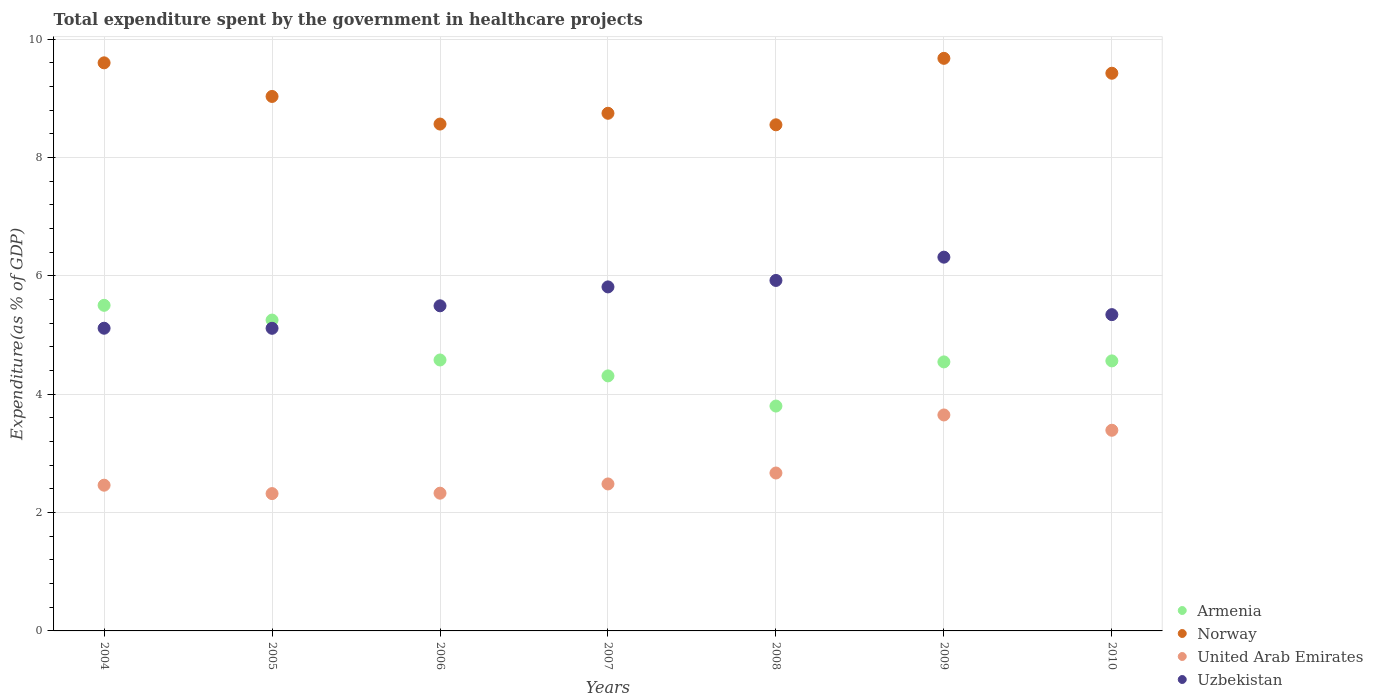What is the total expenditure spent by the government in healthcare projects in United Arab Emirates in 2010?
Make the answer very short. 3.39. Across all years, what is the maximum total expenditure spent by the government in healthcare projects in Uzbekistan?
Provide a succinct answer. 6.31. Across all years, what is the minimum total expenditure spent by the government in healthcare projects in Norway?
Your response must be concise. 8.55. In which year was the total expenditure spent by the government in healthcare projects in Armenia minimum?
Provide a succinct answer. 2008. What is the total total expenditure spent by the government in healthcare projects in Uzbekistan in the graph?
Make the answer very short. 39.11. What is the difference between the total expenditure spent by the government in healthcare projects in Norway in 2008 and that in 2009?
Your response must be concise. -1.12. What is the difference between the total expenditure spent by the government in healthcare projects in Norway in 2006 and the total expenditure spent by the government in healthcare projects in Armenia in 2010?
Make the answer very short. 4. What is the average total expenditure spent by the government in healthcare projects in United Arab Emirates per year?
Offer a terse response. 2.76. In the year 2005, what is the difference between the total expenditure spent by the government in healthcare projects in United Arab Emirates and total expenditure spent by the government in healthcare projects in Uzbekistan?
Provide a succinct answer. -2.79. What is the ratio of the total expenditure spent by the government in healthcare projects in United Arab Emirates in 2005 to that in 2008?
Make the answer very short. 0.87. Is the total expenditure spent by the government in healthcare projects in United Arab Emirates in 2005 less than that in 2006?
Provide a short and direct response. Yes. Is the difference between the total expenditure spent by the government in healthcare projects in United Arab Emirates in 2005 and 2008 greater than the difference between the total expenditure spent by the government in healthcare projects in Uzbekistan in 2005 and 2008?
Offer a very short reply. Yes. What is the difference between the highest and the second highest total expenditure spent by the government in healthcare projects in United Arab Emirates?
Offer a terse response. 0.26. What is the difference between the highest and the lowest total expenditure spent by the government in healthcare projects in Norway?
Your answer should be very brief. 1.12. Does the total expenditure spent by the government in healthcare projects in Uzbekistan monotonically increase over the years?
Your response must be concise. No. Is the total expenditure spent by the government in healthcare projects in United Arab Emirates strictly greater than the total expenditure spent by the government in healthcare projects in Norway over the years?
Make the answer very short. No. Is the total expenditure spent by the government in healthcare projects in Uzbekistan strictly less than the total expenditure spent by the government in healthcare projects in United Arab Emirates over the years?
Offer a terse response. No. How many dotlines are there?
Your answer should be compact. 4. What is the difference between two consecutive major ticks on the Y-axis?
Give a very brief answer. 2. Are the values on the major ticks of Y-axis written in scientific E-notation?
Provide a short and direct response. No. How are the legend labels stacked?
Give a very brief answer. Vertical. What is the title of the graph?
Your answer should be very brief. Total expenditure spent by the government in healthcare projects. Does "Virgin Islands" appear as one of the legend labels in the graph?
Make the answer very short. No. What is the label or title of the X-axis?
Provide a short and direct response. Years. What is the label or title of the Y-axis?
Make the answer very short. Expenditure(as % of GDP). What is the Expenditure(as % of GDP) of Armenia in 2004?
Your answer should be very brief. 5.5. What is the Expenditure(as % of GDP) of Norway in 2004?
Provide a succinct answer. 9.6. What is the Expenditure(as % of GDP) of United Arab Emirates in 2004?
Your response must be concise. 2.46. What is the Expenditure(as % of GDP) in Uzbekistan in 2004?
Make the answer very short. 5.11. What is the Expenditure(as % of GDP) in Armenia in 2005?
Provide a succinct answer. 5.25. What is the Expenditure(as % of GDP) in Norway in 2005?
Your response must be concise. 9.03. What is the Expenditure(as % of GDP) in United Arab Emirates in 2005?
Provide a succinct answer. 2.32. What is the Expenditure(as % of GDP) in Uzbekistan in 2005?
Offer a terse response. 5.11. What is the Expenditure(as % of GDP) in Armenia in 2006?
Your response must be concise. 4.58. What is the Expenditure(as % of GDP) in Norway in 2006?
Make the answer very short. 8.56. What is the Expenditure(as % of GDP) in United Arab Emirates in 2006?
Keep it short and to the point. 2.33. What is the Expenditure(as % of GDP) of Uzbekistan in 2006?
Provide a succinct answer. 5.49. What is the Expenditure(as % of GDP) of Armenia in 2007?
Your answer should be very brief. 4.31. What is the Expenditure(as % of GDP) of Norway in 2007?
Your answer should be very brief. 8.75. What is the Expenditure(as % of GDP) of United Arab Emirates in 2007?
Make the answer very short. 2.48. What is the Expenditure(as % of GDP) of Uzbekistan in 2007?
Provide a short and direct response. 5.81. What is the Expenditure(as % of GDP) in Armenia in 2008?
Keep it short and to the point. 3.8. What is the Expenditure(as % of GDP) in Norway in 2008?
Give a very brief answer. 8.55. What is the Expenditure(as % of GDP) of United Arab Emirates in 2008?
Offer a terse response. 2.67. What is the Expenditure(as % of GDP) in Uzbekistan in 2008?
Your answer should be very brief. 5.92. What is the Expenditure(as % of GDP) of Armenia in 2009?
Provide a short and direct response. 4.55. What is the Expenditure(as % of GDP) of Norway in 2009?
Your answer should be compact. 9.67. What is the Expenditure(as % of GDP) of United Arab Emirates in 2009?
Your response must be concise. 3.65. What is the Expenditure(as % of GDP) in Uzbekistan in 2009?
Provide a succinct answer. 6.31. What is the Expenditure(as % of GDP) of Armenia in 2010?
Keep it short and to the point. 4.56. What is the Expenditure(as % of GDP) of Norway in 2010?
Make the answer very short. 9.42. What is the Expenditure(as % of GDP) of United Arab Emirates in 2010?
Keep it short and to the point. 3.39. What is the Expenditure(as % of GDP) of Uzbekistan in 2010?
Ensure brevity in your answer.  5.34. Across all years, what is the maximum Expenditure(as % of GDP) of Armenia?
Offer a very short reply. 5.5. Across all years, what is the maximum Expenditure(as % of GDP) of Norway?
Give a very brief answer. 9.67. Across all years, what is the maximum Expenditure(as % of GDP) of United Arab Emirates?
Your answer should be compact. 3.65. Across all years, what is the maximum Expenditure(as % of GDP) in Uzbekistan?
Ensure brevity in your answer.  6.31. Across all years, what is the minimum Expenditure(as % of GDP) in Armenia?
Provide a short and direct response. 3.8. Across all years, what is the minimum Expenditure(as % of GDP) of Norway?
Your answer should be very brief. 8.55. Across all years, what is the minimum Expenditure(as % of GDP) in United Arab Emirates?
Provide a succinct answer. 2.32. Across all years, what is the minimum Expenditure(as % of GDP) of Uzbekistan?
Keep it short and to the point. 5.11. What is the total Expenditure(as % of GDP) in Armenia in the graph?
Your response must be concise. 32.55. What is the total Expenditure(as % of GDP) of Norway in the graph?
Give a very brief answer. 63.59. What is the total Expenditure(as % of GDP) in United Arab Emirates in the graph?
Your answer should be compact. 19.3. What is the total Expenditure(as % of GDP) of Uzbekistan in the graph?
Provide a succinct answer. 39.11. What is the difference between the Expenditure(as % of GDP) in Armenia in 2004 and that in 2005?
Give a very brief answer. 0.25. What is the difference between the Expenditure(as % of GDP) in Norway in 2004 and that in 2005?
Offer a terse response. 0.57. What is the difference between the Expenditure(as % of GDP) in United Arab Emirates in 2004 and that in 2005?
Make the answer very short. 0.14. What is the difference between the Expenditure(as % of GDP) of Uzbekistan in 2004 and that in 2005?
Keep it short and to the point. 0. What is the difference between the Expenditure(as % of GDP) in Armenia in 2004 and that in 2006?
Offer a terse response. 0.92. What is the difference between the Expenditure(as % of GDP) of Norway in 2004 and that in 2006?
Keep it short and to the point. 1.03. What is the difference between the Expenditure(as % of GDP) of United Arab Emirates in 2004 and that in 2006?
Offer a terse response. 0.13. What is the difference between the Expenditure(as % of GDP) of Uzbekistan in 2004 and that in 2006?
Your answer should be compact. -0.38. What is the difference between the Expenditure(as % of GDP) in Armenia in 2004 and that in 2007?
Make the answer very short. 1.19. What is the difference between the Expenditure(as % of GDP) of Norway in 2004 and that in 2007?
Your answer should be compact. 0.85. What is the difference between the Expenditure(as % of GDP) in United Arab Emirates in 2004 and that in 2007?
Your answer should be very brief. -0.02. What is the difference between the Expenditure(as % of GDP) of Uzbekistan in 2004 and that in 2007?
Ensure brevity in your answer.  -0.7. What is the difference between the Expenditure(as % of GDP) of Armenia in 2004 and that in 2008?
Your response must be concise. 1.7. What is the difference between the Expenditure(as % of GDP) in Norway in 2004 and that in 2008?
Make the answer very short. 1.05. What is the difference between the Expenditure(as % of GDP) in United Arab Emirates in 2004 and that in 2008?
Your answer should be very brief. -0.21. What is the difference between the Expenditure(as % of GDP) in Uzbekistan in 2004 and that in 2008?
Keep it short and to the point. -0.81. What is the difference between the Expenditure(as % of GDP) of Armenia in 2004 and that in 2009?
Provide a short and direct response. 0.96. What is the difference between the Expenditure(as % of GDP) of Norway in 2004 and that in 2009?
Give a very brief answer. -0.08. What is the difference between the Expenditure(as % of GDP) of United Arab Emirates in 2004 and that in 2009?
Your answer should be compact. -1.19. What is the difference between the Expenditure(as % of GDP) of Uzbekistan in 2004 and that in 2009?
Give a very brief answer. -1.2. What is the difference between the Expenditure(as % of GDP) in Armenia in 2004 and that in 2010?
Offer a very short reply. 0.94. What is the difference between the Expenditure(as % of GDP) of Norway in 2004 and that in 2010?
Ensure brevity in your answer.  0.18. What is the difference between the Expenditure(as % of GDP) in United Arab Emirates in 2004 and that in 2010?
Provide a succinct answer. -0.93. What is the difference between the Expenditure(as % of GDP) in Uzbekistan in 2004 and that in 2010?
Your answer should be very brief. -0.23. What is the difference between the Expenditure(as % of GDP) of Armenia in 2005 and that in 2006?
Provide a short and direct response. 0.67. What is the difference between the Expenditure(as % of GDP) in Norway in 2005 and that in 2006?
Keep it short and to the point. 0.47. What is the difference between the Expenditure(as % of GDP) of United Arab Emirates in 2005 and that in 2006?
Provide a succinct answer. -0.01. What is the difference between the Expenditure(as % of GDP) of Uzbekistan in 2005 and that in 2006?
Provide a short and direct response. -0.38. What is the difference between the Expenditure(as % of GDP) in Armenia in 2005 and that in 2007?
Your response must be concise. 0.94. What is the difference between the Expenditure(as % of GDP) of Norway in 2005 and that in 2007?
Offer a very short reply. 0.28. What is the difference between the Expenditure(as % of GDP) of United Arab Emirates in 2005 and that in 2007?
Provide a short and direct response. -0.16. What is the difference between the Expenditure(as % of GDP) in Uzbekistan in 2005 and that in 2007?
Provide a short and direct response. -0.7. What is the difference between the Expenditure(as % of GDP) of Armenia in 2005 and that in 2008?
Offer a very short reply. 1.45. What is the difference between the Expenditure(as % of GDP) in Norway in 2005 and that in 2008?
Your answer should be compact. 0.48. What is the difference between the Expenditure(as % of GDP) of United Arab Emirates in 2005 and that in 2008?
Offer a terse response. -0.35. What is the difference between the Expenditure(as % of GDP) of Uzbekistan in 2005 and that in 2008?
Ensure brevity in your answer.  -0.81. What is the difference between the Expenditure(as % of GDP) in Armenia in 2005 and that in 2009?
Provide a succinct answer. 0.71. What is the difference between the Expenditure(as % of GDP) in Norway in 2005 and that in 2009?
Your response must be concise. -0.64. What is the difference between the Expenditure(as % of GDP) of United Arab Emirates in 2005 and that in 2009?
Provide a succinct answer. -1.33. What is the difference between the Expenditure(as % of GDP) of Uzbekistan in 2005 and that in 2009?
Offer a very short reply. -1.2. What is the difference between the Expenditure(as % of GDP) of Armenia in 2005 and that in 2010?
Offer a very short reply. 0.69. What is the difference between the Expenditure(as % of GDP) in Norway in 2005 and that in 2010?
Your response must be concise. -0.39. What is the difference between the Expenditure(as % of GDP) of United Arab Emirates in 2005 and that in 2010?
Provide a short and direct response. -1.07. What is the difference between the Expenditure(as % of GDP) in Uzbekistan in 2005 and that in 2010?
Keep it short and to the point. -0.23. What is the difference between the Expenditure(as % of GDP) of Armenia in 2006 and that in 2007?
Offer a terse response. 0.27. What is the difference between the Expenditure(as % of GDP) in Norway in 2006 and that in 2007?
Your answer should be compact. -0.18. What is the difference between the Expenditure(as % of GDP) in United Arab Emirates in 2006 and that in 2007?
Provide a succinct answer. -0.16. What is the difference between the Expenditure(as % of GDP) of Uzbekistan in 2006 and that in 2007?
Provide a short and direct response. -0.32. What is the difference between the Expenditure(as % of GDP) in Armenia in 2006 and that in 2008?
Your response must be concise. 0.78. What is the difference between the Expenditure(as % of GDP) in Norway in 2006 and that in 2008?
Your answer should be compact. 0.01. What is the difference between the Expenditure(as % of GDP) of United Arab Emirates in 2006 and that in 2008?
Give a very brief answer. -0.34. What is the difference between the Expenditure(as % of GDP) in Uzbekistan in 2006 and that in 2008?
Give a very brief answer. -0.43. What is the difference between the Expenditure(as % of GDP) of Armenia in 2006 and that in 2009?
Keep it short and to the point. 0.03. What is the difference between the Expenditure(as % of GDP) of Norway in 2006 and that in 2009?
Your answer should be very brief. -1.11. What is the difference between the Expenditure(as % of GDP) of United Arab Emirates in 2006 and that in 2009?
Your response must be concise. -1.32. What is the difference between the Expenditure(as % of GDP) in Uzbekistan in 2006 and that in 2009?
Your answer should be compact. -0.82. What is the difference between the Expenditure(as % of GDP) of Armenia in 2006 and that in 2010?
Make the answer very short. 0.02. What is the difference between the Expenditure(as % of GDP) of Norway in 2006 and that in 2010?
Your answer should be very brief. -0.86. What is the difference between the Expenditure(as % of GDP) of United Arab Emirates in 2006 and that in 2010?
Offer a very short reply. -1.06. What is the difference between the Expenditure(as % of GDP) in Uzbekistan in 2006 and that in 2010?
Offer a terse response. 0.15. What is the difference between the Expenditure(as % of GDP) of Armenia in 2007 and that in 2008?
Ensure brevity in your answer.  0.51. What is the difference between the Expenditure(as % of GDP) in Norway in 2007 and that in 2008?
Offer a terse response. 0.19. What is the difference between the Expenditure(as % of GDP) in United Arab Emirates in 2007 and that in 2008?
Give a very brief answer. -0.18. What is the difference between the Expenditure(as % of GDP) of Uzbekistan in 2007 and that in 2008?
Your answer should be compact. -0.11. What is the difference between the Expenditure(as % of GDP) of Armenia in 2007 and that in 2009?
Your answer should be very brief. -0.24. What is the difference between the Expenditure(as % of GDP) in Norway in 2007 and that in 2009?
Your answer should be compact. -0.93. What is the difference between the Expenditure(as % of GDP) in United Arab Emirates in 2007 and that in 2009?
Provide a succinct answer. -1.17. What is the difference between the Expenditure(as % of GDP) of Uzbekistan in 2007 and that in 2009?
Provide a succinct answer. -0.5. What is the difference between the Expenditure(as % of GDP) in Armenia in 2007 and that in 2010?
Offer a terse response. -0.25. What is the difference between the Expenditure(as % of GDP) of Norway in 2007 and that in 2010?
Your response must be concise. -0.68. What is the difference between the Expenditure(as % of GDP) of United Arab Emirates in 2007 and that in 2010?
Offer a terse response. -0.91. What is the difference between the Expenditure(as % of GDP) of Uzbekistan in 2007 and that in 2010?
Provide a short and direct response. 0.47. What is the difference between the Expenditure(as % of GDP) of Armenia in 2008 and that in 2009?
Provide a short and direct response. -0.75. What is the difference between the Expenditure(as % of GDP) of Norway in 2008 and that in 2009?
Your response must be concise. -1.12. What is the difference between the Expenditure(as % of GDP) of United Arab Emirates in 2008 and that in 2009?
Provide a short and direct response. -0.98. What is the difference between the Expenditure(as % of GDP) of Uzbekistan in 2008 and that in 2009?
Ensure brevity in your answer.  -0.39. What is the difference between the Expenditure(as % of GDP) in Armenia in 2008 and that in 2010?
Your answer should be compact. -0.76. What is the difference between the Expenditure(as % of GDP) of Norway in 2008 and that in 2010?
Keep it short and to the point. -0.87. What is the difference between the Expenditure(as % of GDP) in United Arab Emirates in 2008 and that in 2010?
Make the answer very short. -0.72. What is the difference between the Expenditure(as % of GDP) of Uzbekistan in 2008 and that in 2010?
Ensure brevity in your answer.  0.58. What is the difference between the Expenditure(as % of GDP) of Armenia in 2009 and that in 2010?
Offer a terse response. -0.02. What is the difference between the Expenditure(as % of GDP) of Norway in 2009 and that in 2010?
Provide a succinct answer. 0.25. What is the difference between the Expenditure(as % of GDP) in United Arab Emirates in 2009 and that in 2010?
Your answer should be compact. 0.26. What is the difference between the Expenditure(as % of GDP) in Uzbekistan in 2009 and that in 2010?
Give a very brief answer. 0.97. What is the difference between the Expenditure(as % of GDP) of Armenia in 2004 and the Expenditure(as % of GDP) of Norway in 2005?
Keep it short and to the point. -3.53. What is the difference between the Expenditure(as % of GDP) of Armenia in 2004 and the Expenditure(as % of GDP) of United Arab Emirates in 2005?
Give a very brief answer. 3.18. What is the difference between the Expenditure(as % of GDP) in Armenia in 2004 and the Expenditure(as % of GDP) in Uzbekistan in 2005?
Offer a terse response. 0.39. What is the difference between the Expenditure(as % of GDP) in Norway in 2004 and the Expenditure(as % of GDP) in United Arab Emirates in 2005?
Ensure brevity in your answer.  7.28. What is the difference between the Expenditure(as % of GDP) of Norway in 2004 and the Expenditure(as % of GDP) of Uzbekistan in 2005?
Offer a very short reply. 4.49. What is the difference between the Expenditure(as % of GDP) in United Arab Emirates in 2004 and the Expenditure(as % of GDP) in Uzbekistan in 2005?
Offer a terse response. -2.65. What is the difference between the Expenditure(as % of GDP) of Armenia in 2004 and the Expenditure(as % of GDP) of Norway in 2006?
Your answer should be compact. -3.06. What is the difference between the Expenditure(as % of GDP) of Armenia in 2004 and the Expenditure(as % of GDP) of United Arab Emirates in 2006?
Your answer should be very brief. 3.17. What is the difference between the Expenditure(as % of GDP) in Armenia in 2004 and the Expenditure(as % of GDP) in Uzbekistan in 2006?
Your answer should be compact. 0.01. What is the difference between the Expenditure(as % of GDP) of Norway in 2004 and the Expenditure(as % of GDP) of United Arab Emirates in 2006?
Provide a short and direct response. 7.27. What is the difference between the Expenditure(as % of GDP) in Norway in 2004 and the Expenditure(as % of GDP) in Uzbekistan in 2006?
Your response must be concise. 4.11. What is the difference between the Expenditure(as % of GDP) in United Arab Emirates in 2004 and the Expenditure(as % of GDP) in Uzbekistan in 2006?
Offer a very short reply. -3.03. What is the difference between the Expenditure(as % of GDP) of Armenia in 2004 and the Expenditure(as % of GDP) of Norway in 2007?
Provide a short and direct response. -3.24. What is the difference between the Expenditure(as % of GDP) of Armenia in 2004 and the Expenditure(as % of GDP) of United Arab Emirates in 2007?
Make the answer very short. 3.02. What is the difference between the Expenditure(as % of GDP) in Armenia in 2004 and the Expenditure(as % of GDP) in Uzbekistan in 2007?
Keep it short and to the point. -0.31. What is the difference between the Expenditure(as % of GDP) in Norway in 2004 and the Expenditure(as % of GDP) in United Arab Emirates in 2007?
Your response must be concise. 7.11. What is the difference between the Expenditure(as % of GDP) in Norway in 2004 and the Expenditure(as % of GDP) in Uzbekistan in 2007?
Keep it short and to the point. 3.79. What is the difference between the Expenditure(as % of GDP) in United Arab Emirates in 2004 and the Expenditure(as % of GDP) in Uzbekistan in 2007?
Your response must be concise. -3.35. What is the difference between the Expenditure(as % of GDP) in Armenia in 2004 and the Expenditure(as % of GDP) in Norway in 2008?
Your answer should be very brief. -3.05. What is the difference between the Expenditure(as % of GDP) of Armenia in 2004 and the Expenditure(as % of GDP) of United Arab Emirates in 2008?
Your response must be concise. 2.83. What is the difference between the Expenditure(as % of GDP) of Armenia in 2004 and the Expenditure(as % of GDP) of Uzbekistan in 2008?
Provide a short and direct response. -0.42. What is the difference between the Expenditure(as % of GDP) of Norway in 2004 and the Expenditure(as % of GDP) of United Arab Emirates in 2008?
Offer a very short reply. 6.93. What is the difference between the Expenditure(as % of GDP) of Norway in 2004 and the Expenditure(as % of GDP) of Uzbekistan in 2008?
Offer a very short reply. 3.68. What is the difference between the Expenditure(as % of GDP) in United Arab Emirates in 2004 and the Expenditure(as % of GDP) in Uzbekistan in 2008?
Provide a short and direct response. -3.46. What is the difference between the Expenditure(as % of GDP) in Armenia in 2004 and the Expenditure(as % of GDP) in Norway in 2009?
Ensure brevity in your answer.  -4.17. What is the difference between the Expenditure(as % of GDP) of Armenia in 2004 and the Expenditure(as % of GDP) of United Arab Emirates in 2009?
Provide a succinct answer. 1.85. What is the difference between the Expenditure(as % of GDP) of Armenia in 2004 and the Expenditure(as % of GDP) of Uzbekistan in 2009?
Offer a very short reply. -0.81. What is the difference between the Expenditure(as % of GDP) in Norway in 2004 and the Expenditure(as % of GDP) in United Arab Emirates in 2009?
Provide a short and direct response. 5.95. What is the difference between the Expenditure(as % of GDP) in Norway in 2004 and the Expenditure(as % of GDP) in Uzbekistan in 2009?
Offer a very short reply. 3.28. What is the difference between the Expenditure(as % of GDP) in United Arab Emirates in 2004 and the Expenditure(as % of GDP) in Uzbekistan in 2009?
Give a very brief answer. -3.85. What is the difference between the Expenditure(as % of GDP) in Armenia in 2004 and the Expenditure(as % of GDP) in Norway in 2010?
Your response must be concise. -3.92. What is the difference between the Expenditure(as % of GDP) in Armenia in 2004 and the Expenditure(as % of GDP) in United Arab Emirates in 2010?
Give a very brief answer. 2.11. What is the difference between the Expenditure(as % of GDP) of Armenia in 2004 and the Expenditure(as % of GDP) of Uzbekistan in 2010?
Ensure brevity in your answer.  0.16. What is the difference between the Expenditure(as % of GDP) in Norway in 2004 and the Expenditure(as % of GDP) in United Arab Emirates in 2010?
Your answer should be very brief. 6.21. What is the difference between the Expenditure(as % of GDP) in Norway in 2004 and the Expenditure(as % of GDP) in Uzbekistan in 2010?
Offer a very short reply. 4.25. What is the difference between the Expenditure(as % of GDP) in United Arab Emirates in 2004 and the Expenditure(as % of GDP) in Uzbekistan in 2010?
Offer a very short reply. -2.88. What is the difference between the Expenditure(as % of GDP) of Armenia in 2005 and the Expenditure(as % of GDP) of Norway in 2006?
Ensure brevity in your answer.  -3.31. What is the difference between the Expenditure(as % of GDP) of Armenia in 2005 and the Expenditure(as % of GDP) of United Arab Emirates in 2006?
Provide a short and direct response. 2.92. What is the difference between the Expenditure(as % of GDP) in Armenia in 2005 and the Expenditure(as % of GDP) in Uzbekistan in 2006?
Make the answer very short. -0.24. What is the difference between the Expenditure(as % of GDP) of Norway in 2005 and the Expenditure(as % of GDP) of United Arab Emirates in 2006?
Your answer should be very brief. 6.7. What is the difference between the Expenditure(as % of GDP) of Norway in 2005 and the Expenditure(as % of GDP) of Uzbekistan in 2006?
Provide a short and direct response. 3.54. What is the difference between the Expenditure(as % of GDP) of United Arab Emirates in 2005 and the Expenditure(as % of GDP) of Uzbekistan in 2006?
Provide a short and direct response. -3.17. What is the difference between the Expenditure(as % of GDP) of Armenia in 2005 and the Expenditure(as % of GDP) of Norway in 2007?
Ensure brevity in your answer.  -3.49. What is the difference between the Expenditure(as % of GDP) in Armenia in 2005 and the Expenditure(as % of GDP) in United Arab Emirates in 2007?
Ensure brevity in your answer.  2.77. What is the difference between the Expenditure(as % of GDP) of Armenia in 2005 and the Expenditure(as % of GDP) of Uzbekistan in 2007?
Offer a terse response. -0.56. What is the difference between the Expenditure(as % of GDP) in Norway in 2005 and the Expenditure(as % of GDP) in United Arab Emirates in 2007?
Provide a succinct answer. 6.55. What is the difference between the Expenditure(as % of GDP) of Norway in 2005 and the Expenditure(as % of GDP) of Uzbekistan in 2007?
Offer a terse response. 3.22. What is the difference between the Expenditure(as % of GDP) in United Arab Emirates in 2005 and the Expenditure(as % of GDP) in Uzbekistan in 2007?
Provide a short and direct response. -3.49. What is the difference between the Expenditure(as % of GDP) of Armenia in 2005 and the Expenditure(as % of GDP) of Norway in 2008?
Give a very brief answer. -3.3. What is the difference between the Expenditure(as % of GDP) in Armenia in 2005 and the Expenditure(as % of GDP) in United Arab Emirates in 2008?
Keep it short and to the point. 2.58. What is the difference between the Expenditure(as % of GDP) in Armenia in 2005 and the Expenditure(as % of GDP) in Uzbekistan in 2008?
Your answer should be compact. -0.67. What is the difference between the Expenditure(as % of GDP) in Norway in 2005 and the Expenditure(as % of GDP) in United Arab Emirates in 2008?
Give a very brief answer. 6.36. What is the difference between the Expenditure(as % of GDP) in Norway in 2005 and the Expenditure(as % of GDP) in Uzbekistan in 2008?
Make the answer very short. 3.11. What is the difference between the Expenditure(as % of GDP) in United Arab Emirates in 2005 and the Expenditure(as % of GDP) in Uzbekistan in 2008?
Provide a succinct answer. -3.6. What is the difference between the Expenditure(as % of GDP) in Armenia in 2005 and the Expenditure(as % of GDP) in Norway in 2009?
Ensure brevity in your answer.  -4.42. What is the difference between the Expenditure(as % of GDP) in Armenia in 2005 and the Expenditure(as % of GDP) in United Arab Emirates in 2009?
Keep it short and to the point. 1.6. What is the difference between the Expenditure(as % of GDP) of Armenia in 2005 and the Expenditure(as % of GDP) of Uzbekistan in 2009?
Make the answer very short. -1.06. What is the difference between the Expenditure(as % of GDP) of Norway in 2005 and the Expenditure(as % of GDP) of United Arab Emirates in 2009?
Your answer should be compact. 5.38. What is the difference between the Expenditure(as % of GDP) in Norway in 2005 and the Expenditure(as % of GDP) in Uzbekistan in 2009?
Keep it short and to the point. 2.72. What is the difference between the Expenditure(as % of GDP) in United Arab Emirates in 2005 and the Expenditure(as % of GDP) in Uzbekistan in 2009?
Offer a terse response. -3.99. What is the difference between the Expenditure(as % of GDP) in Armenia in 2005 and the Expenditure(as % of GDP) in Norway in 2010?
Your answer should be compact. -4.17. What is the difference between the Expenditure(as % of GDP) of Armenia in 2005 and the Expenditure(as % of GDP) of United Arab Emirates in 2010?
Give a very brief answer. 1.86. What is the difference between the Expenditure(as % of GDP) in Armenia in 2005 and the Expenditure(as % of GDP) in Uzbekistan in 2010?
Your response must be concise. -0.09. What is the difference between the Expenditure(as % of GDP) of Norway in 2005 and the Expenditure(as % of GDP) of United Arab Emirates in 2010?
Make the answer very short. 5.64. What is the difference between the Expenditure(as % of GDP) in Norway in 2005 and the Expenditure(as % of GDP) in Uzbekistan in 2010?
Provide a short and direct response. 3.69. What is the difference between the Expenditure(as % of GDP) of United Arab Emirates in 2005 and the Expenditure(as % of GDP) of Uzbekistan in 2010?
Make the answer very short. -3.02. What is the difference between the Expenditure(as % of GDP) of Armenia in 2006 and the Expenditure(as % of GDP) of Norway in 2007?
Make the answer very short. -4.17. What is the difference between the Expenditure(as % of GDP) in Armenia in 2006 and the Expenditure(as % of GDP) in United Arab Emirates in 2007?
Give a very brief answer. 2.09. What is the difference between the Expenditure(as % of GDP) of Armenia in 2006 and the Expenditure(as % of GDP) of Uzbekistan in 2007?
Your answer should be very brief. -1.23. What is the difference between the Expenditure(as % of GDP) in Norway in 2006 and the Expenditure(as % of GDP) in United Arab Emirates in 2007?
Offer a very short reply. 6.08. What is the difference between the Expenditure(as % of GDP) in Norway in 2006 and the Expenditure(as % of GDP) in Uzbekistan in 2007?
Your answer should be compact. 2.75. What is the difference between the Expenditure(as % of GDP) of United Arab Emirates in 2006 and the Expenditure(as % of GDP) of Uzbekistan in 2007?
Give a very brief answer. -3.49. What is the difference between the Expenditure(as % of GDP) in Armenia in 2006 and the Expenditure(as % of GDP) in Norway in 2008?
Make the answer very short. -3.97. What is the difference between the Expenditure(as % of GDP) in Armenia in 2006 and the Expenditure(as % of GDP) in United Arab Emirates in 2008?
Provide a short and direct response. 1.91. What is the difference between the Expenditure(as % of GDP) of Armenia in 2006 and the Expenditure(as % of GDP) of Uzbekistan in 2008?
Offer a terse response. -1.34. What is the difference between the Expenditure(as % of GDP) of Norway in 2006 and the Expenditure(as % of GDP) of United Arab Emirates in 2008?
Your answer should be compact. 5.9. What is the difference between the Expenditure(as % of GDP) of Norway in 2006 and the Expenditure(as % of GDP) of Uzbekistan in 2008?
Give a very brief answer. 2.64. What is the difference between the Expenditure(as % of GDP) in United Arab Emirates in 2006 and the Expenditure(as % of GDP) in Uzbekistan in 2008?
Your answer should be very brief. -3.59. What is the difference between the Expenditure(as % of GDP) in Armenia in 2006 and the Expenditure(as % of GDP) in Norway in 2009?
Keep it short and to the point. -5.1. What is the difference between the Expenditure(as % of GDP) of Armenia in 2006 and the Expenditure(as % of GDP) of United Arab Emirates in 2009?
Your answer should be compact. 0.93. What is the difference between the Expenditure(as % of GDP) of Armenia in 2006 and the Expenditure(as % of GDP) of Uzbekistan in 2009?
Provide a short and direct response. -1.74. What is the difference between the Expenditure(as % of GDP) in Norway in 2006 and the Expenditure(as % of GDP) in United Arab Emirates in 2009?
Provide a succinct answer. 4.92. What is the difference between the Expenditure(as % of GDP) of Norway in 2006 and the Expenditure(as % of GDP) of Uzbekistan in 2009?
Keep it short and to the point. 2.25. What is the difference between the Expenditure(as % of GDP) in United Arab Emirates in 2006 and the Expenditure(as % of GDP) in Uzbekistan in 2009?
Ensure brevity in your answer.  -3.99. What is the difference between the Expenditure(as % of GDP) in Armenia in 2006 and the Expenditure(as % of GDP) in Norway in 2010?
Keep it short and to the point. -4.84. What is the difference between the Expenditure(as % of GDP) in Armenia in 2006 and the Expenditure(as % of GDP) in United Arab Emirates in 2010?
Your answer should be compact. 1.19. What is the difference between the Expenditure(as % of GDP) in Armenia in 2006 and the Expenditure(as % of GDP) in Uzbekistan in 2010?
Provide a short and direct response. -0.77. What is the difference between the Expenditure(as % of GDP) in Norway in 2006 and the Expenditure(as % of GDP) in United Arab Emirates in 2010?
Offer a very short reply. 5.17. What is the difference between the Expenditure(as % of GDP) of Norway in 2006 and the Expenditure(as % of GDP) of Uzbekistan in 2010?
Offer a very short reply. 3.22. What is the difference between the Expenditure(as % of GDP) in United Arab Emirates in 2006 and the Expenditure(as % of GDP) in Uzbekistan in 2010?
Offer a very short reply. -3.02. What is the difference between the Expenditure(as % of GDP) in Armenia in 2007 and the Expenditure(as % of GDP) in Norway in 2008?
Your answer should be very brief. -4.24. What is the difference between the Expenditure(as % of GDP) of Armenia in 2007 and the Expenditure(as % of GDP) of United Arab Emirates in 2008?
Your answer should be very brief. 1.64. What is the difference between the Expenditure(as % of GDP) of Armenia in 2007 and the Expenditure(as % of GDP) of Uzbekistan in 2008?
Give a very brief answer. -1.61. What is the difference between the Expenditure(as % of GDP) of Norway in 2007 and the Expenditure(as % of GDP) of United Arab Emirates in 2008?
Provide a short and direct response. 6.08. What is the difference between the Expenditure(as % of GDP) in Norway in 2007 and the Expenditure(as % of GDP) in Uzbekistan in 2008?
Keep it short and to the point. 2.82. What is the difference between the Expenditure(as % of GDP) of United Arab Emirates in 2007 and the Expenditure(as % of GDP) of Uzbekistan in 2008?
Ensure brevity in your answer.  -3.44. What is the difference between the Expenditure(as % of GDP) of Armenia in 2007 and the Expenditure(as % of GDP) of Norway in 2009?
Your answer should be compact. -5.37. What is the difference between the Expenditure(as % of GDP) of Armenia in 2007 and the Expenditure(as % of GDP) of United Arab Emirates in 2009?
Keep it short and to the point. 0.66. What is the difference between the Expenditure(as % of GDP) in Armenia in 2007 and the Expenditure(as % of GDP) in Uzbekistan in 2009?
Provide a short and direct response. -2.01. What is the difference between the Expenditure(as % of GDP) of Norway in 2007 and the Expenditure(as % of GDP) of United Arab Emirates in 2009?
Ensure brevity in your answer.  5.1. What is the difference between the Expenditure(as % of GDP) in Norway in 2007 and the Expenditure(as % of GDP) in Uzbekistan in 2009?
Your answer should be very brief. 2.43. What is the difference between the Expenditure(as % of GDP) in United Arab Emirates in 2007 and the Expenditure(as % of GDP) in Uzbekistan in 2009?
Ensure brevity in your answer.  -3.83. What is the difference between the Expenditure(as % of GDP) in Armenia in 2007 and the Expenditure(as % of GDP) in Norway in 2010?
Your response must be concise. -5.11. What is the difference between the Expenditure(as % of GDP) of Armenia in 2007 and the Expenditure(as % of GDP) of United Arab Emirates in 2010?
Offer a very short reply. 0.92. What is the difference between the Expenditure(as % of GDP) of Armenia in 2007 and the Expenditure(as % of GDP) of Uzbekistan in 2010?
Offer a very short reply. -1.04. What is the difference between the Expenditure(as % of GDP) in Norway in 2007 and the Expenditure(as % of GDP) in United Arab Emirates in 2010?
Your answer should be compact. 5.36. What is the difference between the Expenditure(as % of GDP) of Norway in 2007 and the Expenditure(as % of GDP) of Uzbekistan in 2010?
Your answer should be very brief. 3.4. What is the difference between the Expenditure(as % of GDP) in United Arab Emirates in 2007 and the Expenditure(as % of GDP) in Uzbekistan in 2010?
Give a very brief answer. -2.86. What is the difference between the Expenditure(as % of GDP) in Armenia in 2008 and the Expenditure(as % of GDP) in Norway in 2009?
Your answer should be very brief. -5.87. What is the difference between the Expenditure(as % of GDP) of Armenia in 2008 and the Expenditure(as % of GDP) of United Arab Emirates in 2009?
Your answer should be compact. 0.15. What is the difference between the Expenditure(as % of GDP) in Armenia in 2008 and the Expenditure(as % of GDP) in Uzbekistan in 2009?
Offer a terse response. -2.52. What is the difference between the Expenditure(as % of GDP) in Norway in 2008 and the Expenditure(as % of GDP) in United Arab Emirates in 2009?
Your answer should be very brief. 4.9. What is the difference between the Expenditure(as % of GDP) of Norway in 2008 and the Expenditure(as % of GDP) of Uzbekistan in 2009?
Ensure brevity in your answer.  2.24. What is the difference between the Expenditure(as % of GDP) of United Arab Emirates in 2008 and the Expenditure(as % of GDP) of Uzbekistan in 2009?
Provide a short and direct response. -3.65. What is the difference between the Expenditure(as % of GDP) of Armenia in 2008 and the Expenditure(as % of GDP) of Norway in 2010?
Offer a very short reply. -5.62. What is the difference between the Expenditure(as % of GDP) of Armenia in 2008 and the Expenditure(as % of GDP) of United Arab Emirates in 2010?
Offer a terse response. 0.41. What is the difference between the Expenditure(as % of GDP) in Armenia in 2008 and the Expenditure(as % of GDP) in Uzbekistan in 2010?
Provide a short and direct response. -1.54. What is the difference between the Expenditure(as % of GDP) of Norway in 2008 and the Expenditure(as % of GDP) of United Arab Emirates in 2010?
Your answer should be compact. 5.16. What is the difference between the Expenditure(as % of GDP) of Norway in 2008 and the Expenditure(as % of GDP) of Uzbekistan in 2010?
Provide a short and direct response. 3.21. What is the difference between the Expenditure(as % of GDP) of United Arab Emirates in 2008 and the Expenditure(as % of GDP) of Uzbekistan in 2010?
Make the answer very short. -2.68. What is the difference between the Expenditure(as % of GDP) of Armenia in 2009 and the Expenditure(as % of GDP) of Norway in 2010?
Your response must be concise. -4.88. What is the difference between the Expenditure(as % of GDP) in Armenia in 2009 and the Expenditure(as % of GDP) in United Arab Emirates in 2010?
Ensure brevity in your answer.  1.15. What is the difference between the Expenditure(as % of GDP) in Armenia in 2009 and the Expenditure(as % of GDP) in Uzbekistan in 2010?
Make the answer very short. -0.8. What is the difference between the Expenditure(as % of GDP) of Norway in 2009 and the Expenditure(as % of GDP) of United Arab Emirates in 2010?
Your response must be concise. 6.28. What is the difference between the Expenditure(as % of GDP) in Norway in 2009 and the Expenditure(as % of GDP) in Uzbekistan in 2010?
Your response must be concise. 4.33. What is the difference between the Expenditure(as % of GDP) in United Arab Emirates in 2009 and the Expenditure(as % of GDP) in Uzbekistan in 2010?
Offer a very short reply. -1.7. What is the average Expenditure(as % of GDP) of Armenia per year?
Your answer should be very brief. 4.65. What is the average Expenditure(as % of GDP) in Norway per year?
Provide a succinct answer. 9.08. What is the average Expenditure(as % of GDP) in United Arab Emirates per year?
Provide a short and direct response. 2.76. What is the average Expenditure(as % of GDP) of Uzbekistan per year?
Offer a very short reply. 5.59. In the year 2004, what is the difference between the Expenditure(as % of GDP) in Armenia and Expenditure(as % of GDP) in Norway?
Ensure brevity in your answer.  -4.1. In the year 2004, what is the difference between the Expenditure(as % of GDP) of Armenia and Expenditure(as % of GDP) of United Arab Emirates?
Provide a short and direct response. 3.04. In the year 2004, what is the difference between the Expenditure(as % of GDP) of Armenia and Expenditure(as % of GDP) of Uzbekistan?
Your response must be concise. 0.39. In the year 2004, what is the difference between the Expenditure(as % of GDP) in Norway and Expenditure(as % of GDP) in United Arab Emirates?
Provide a short and direct response. 7.14. In the year 2004, what is the difference between the Expenditure(as % of GDP) of Norway and Expenditure(as % of GDP) of Uzbekistan?
Keep it short and to the point. 4.48. In the year 2004, what is the difference between the Expenditure(as % of GDP) of United Arab Emirates and Expenditure(as % of GDP) of Uzbekistan?
Ensure brevity in your answer.  -2.65. In the year 2005, what is the difference between the Expenditure(as % of GDP) in Armenia and Expenditure(as % of GDP) in Norway?
Provide a succinct answer. -3.78. In the year 2005, what is the difference between the Expenditure(as % of GDP) in Armenia and Expenditure(as % of GDP) in United Arab Emirates?
Provide a succinct answer. 2.93. In the year 2005, what is the difference between the Expenditure(as % of GDP) of Armenia and Expenditure(as % of GDP) of Uzbekistan?
Offer a very short reply. 0.14. In the year 2005, what is the difference between the Expenditure(as % of GDP) in Norway and Expenditure(as % of GDP) in United Arab Emirates?
Keep it short and to the point. 6.71. In the year 2005, what is the difference between the Expenditure(as % of GDP) of Norway and Expenditure(as % of GDP) of Uzbekistan?
Offer a terse response. 3.92. In the year 2005, what is the difference between the Expenditure(as % of GDP) in United Arab Emirates and Expenditure(as % of GDP) in Uzbekistan?
Your answer should be very brief. -2.79. In the year 2006, what is the difference between the Expenditure(as % of GDP) in Armenia and Expenditure(as % of GDP) in Norway?
Ensure brevity in your answer.  -3.99. In the year 2006, what is the difference between the Expenditure(as % of GDP) of Armenia and Expenditure(as % of GDP) of United Arab Emirates?
Offer a terse response. 2.25. In the year 2006, what is the difference between the Expenditure(as % of GDP) in Armenia and Expenditure(as % of GDP) in Uzbekistan?
Offer a very short reply. -0.92. In the year 2006, what is the difference between the Expenditure(as % of GDP) of Norway and Expenditure(as % of GDP) of United Arab Emirates?
Provide a succinct answer. 6.24. In the year 2006, what is the difference between the Expenditure(as % of GDP) of Norway and Expenditure(as % of GDP) of Uzbekistan?
Your answer should be compact. 3.07. In the year 2006, what is the difference between the Expenditure(as % of GDP) of United Arab Emirates and Expenditure(as % of GDP) of Uzbekistan?
Offer a very short reply. -3.17. In the year 2007, what is the difference between the Expenditure(as % of GDP) of Armenia and Expenditure(as % of GDP) of Norway?
Keep it short and to the point. -4.44. In the year 2007, what is the difference between the Expenditure(as % of GDP) in Armenia and Expenditure(as % of GDP) in United Arab Emirates?
Ensure brevity in your answer.  1.83. In the year 2007, what is the difference between the Expenditure(as % of GDP) of Armenia and Expenditure(as % of GDP) of Uzbekistan?
Provide a succinct answer. -1.5. In the year 2007, what is the difference between the Expenditure(as % of GDP) of Norway and Expenditure(as % of GDP) of United Arab Emirates?
Offer a very short reply. 6.26. In the year 2007, what is the difference between the Expenditure(as % of GDP) of Norway and Expenditure(as % of GDP) of Uzbekistan?
Keep it short and to the point. 2.93. In the year 2007, what is the difference between the Expenditure(as % of GDP) of United Arab Emirates and Expenditure(as % of GDP) of Uzbekistan?
Make the answer very short. -3.33. In the year 2008, what is the difference between the Expenditure(as % of GDP) of Armenia and Expenditure(as % of GDP) of Norway?
Provide a short and direct response. -4.75. In the year 2008, what is the difference between the Expenditure(as % of GDP) in Armenia and Expenditure(as % of GDP) in United Arab Emirates?
Ensure brevity in your answer.  1.13. In the year 2008, what is the difference between the Expenditure(as % of GDP) in Armenia and Expenditure(as % of GDP) in Uzbekistan?
Your response must be concise. -2.12. In the year 2008, what is the difference between the Expenditure(as % of GDP) of Norway and Expenditure(as % of GDP) of United Arab Emirates?
Offer a very short reply. 5.88. In the year 2008, what is the difference between the Expenditure(as % of GDP) of Norway and Expenditure(as % of GDP) of Uzbekistan?
Keep it short and to the point. 2.63. In the year 2008, what is the difference between the Expenditure(as % of GDP) of United Arab Emirates and Expenditure(as % of GDP) of Uzbekistan?
Offer a very short reply. -3.25. In the year 2009, what is the difference between the Expenditure(as % of GDP) of Armenia and Expenditure(as % of GDP) of Norway?
Give a very brief answer. -5.13. In the year 2009, what is the difference between the Expenditure(as % of GDP) of Armenia and Expenditure(as % of GDP) of United Arab Emirates?
Provide a short and direct response. 0.9. In the year 2009, what is the difference between the Expenditure(as % of GDP) in Armenia and Expenditure(as % of GDP) in Uzbekistan?
Your answer should be compact. -1.77. In the year 2009, what is the difference between the Expenditure(as % of GDP) of Norway and Expenditure(as % of GDP) of United Arab Emirates?
Your response must be concise. 6.03. In the year 2009, what is the difference between the Expenditure(as % of GDP) of Norway and Expenditure(as % of GDP) of Uzbekistan?
Make the answer very short. 3.36. In the year 2009, what is the difference between the Expenditure(as % of GDP) of United Arab Emirates and Expenditure(as % of GDP) of Uzbekistan?
Offer a terse response. -2.67. In the year 2010, what is the difference between the Expenditure(as % of GDP) in Armenia and Expenditure(as % of GDP) in Norway?
Provide a short and direct response. -4.86. In the year 2010, what is the difference between the Expenditure(as % of GDP) of Armenia and Expenditure(as % of GDP) of United Arab Emirates?
Your answer should be very brief. 1.17. In the year 2010, what is the difference between the Expenditure(as % of GDP) in Armenia and Expenditure(as % of GDP) in Uzbekistan?
Offer a very short reply. -0.78. In the year 2010, what is the difference between the Expenditure(as % of GDP) of Norway and Expenditure(as % of GDP) of United Arab Emirates?
Provide a short and direct response. 6.03. In the year 2010, what is the difference between the Expenditure(as % of GDP) in Norway and Expenditure(as % of GDP) in Uzbekistan?
Provide a succinct answer. 4.08. In the year 2010, what is the difference between the Expenditure(as % of GDP) in United Arab Emirates and Expenditure(as % of GDP) in Uzbekistan?
Ensure brevity in your answer.  -1.95. What is the ratio of the Expenditure(as % of GDP) of Armenia in 2004 to that in 2005?
Keep it short and to the point. 1.05. What is the ratio of the Expenditure(as % of GDP) in Norway in 2004 to that in 2005?
Offer a terse response. 1.06. What is the ratio of the Expenditure(as % of GDP) in United Arab Emirates in 2004 to that in 2005?
Provide a short and direct response. 1.06. What is the ratio of the Expenditure(as % of GDP) of Uzbekistan in 2004 to that in 2005?
Give a very brief answer. 1. What is the ratio of the Expenditure(as % of GDP) in Armenia in 2004 to that in 2006?
Your answer should be compact. 1.2. What is the ratio of the Expenditure(as % of GDP) in Norway in 2004 to that in 2006?
Your answer should be compact. 1.12. What is the ratio of the Expenditure(as % of GDP) of United Arab Emirates in 2004 to that in 2006?
Make the answer very short. 1.06. What is the ratio of the Expenditure(as % of GDP) in Uzbekistan in 2004 to that in 2006?
Give a very brief answer. 0.93. What is the ratio of the Expenditure(as % of GDP) in Armenia in 2004 to that in 2007?
Provide a succinct answer. 1.28. What is the ratio of the Expenditure(as % of GDP) in Norway in 2004 to that in 2007?
Offer a very short reply. 1.1. What is the ratio of the Expenditure(as % of GDP) in Uzbekistan in 2004 to that in 2007?
Ensure brevity in your answer.  0.88. What is the ratio of the Expenditure(as % of GDP) in Armenia in 2004 to that in 2008?
Ensure brevity in your answer.  1.45. What is the ratio of the Expenditure(as % of GDP) of Norway in 2004 to that in 2008?
Make the answer very short. 1.12. What is the ratio of the Expenditure(as % of GDP) in United Arab Emirates in 2004 to that in 2008?
Your response must be concise. 0.92. What is the ratio of the Expenditure(as % of GDP) in Uzbekistan in 2004 to that in 2008?
Provide a short and direct response. 0.86. What is the ratio of the Expenditure(as % of GDP) of Armenia in 2004 to that in 2009?
Offer a terse response. 1.21. What is the ratio of the Expenditure(as % of GDP) in Norway in 2004 to that in 2009?
Offer a terse response. 0.99. What is the ratio of the Expenditure(as % of GDP) in United Arab Emirates in 2004 to that in 2009?
Your response must be concise. 0.67. What is the ratio of the Expenditure(as % of GDP) in Uzbekistan in 2004 to that in 2009?
Provide a succinct answer. 0.81. What is the ratio of the Expenditure(as % of GDP) of Armenia in 2004 to that in 2010?
Make the answer very short. 1.21. What is the ratio of the Expenditure(as % of GDP) of Norway in 2004 to that in 2010?
Give a very brief answer. 1.02. What is the ratio of the Expenditure(as % of GDP) in United Arab Emirates in 2004 to that in 2010?
Your answer should be compact. 0.73. What is the ratio of the Expenditure(as % of GDP) of Uzbekistan in 2004 to that in 2010?
Make the answer very short. 0.96. What is the ratio of the Expenditure(as % of GDP) in Armenia in 2005 to that in 2006?
Keep it short and to the point. 1.15. What is the ratio of the Expenditure(as % of GDP) in Norway in 2005 to that in 2006?
Make the answer very short. 1.05. What is the ratio of the Expenditure(as % of GDP) of United Arab Emirates in 2005 to that in 2006?
Offer a very short reply. 1. What is the ratio of the Expenditure(as % of GDP) of Uzbekistan in 2005 to that in 2006?
Make the answer very short. 0.93. What is the ratio of the Expenditure(as % of GDP) of Armenia in 2005 to that in 2007?
Make the answer very short. 1.22. What is the ratio of the Expenditure(as % of GDP) in Norway in 2005 to that in 2007?
Provide a short and direct response. 1.03. What is the ratio of the Expenditure(as % of GDP) of United Arab Emirates in 2005 to that in 2007?
Offer a terse response. 0.93. What is the ratio of the Expenditure(as % of GDP) of Uzbekistan in 2005 to that in 2007?
Give a very brief answer. 0.88. What is the ratio of the Expenditure(as % of GDP) of Armenia in 2005 to that in 2008?
Provide a short and direct response. 1.38. What is the ratio of the Expenditure(as % of GDP) of Norway in 2005 to that in 2008?
Your answer should be compact. 1.06. What is the ratio of the Expenditure(as % of GDP) of United Arab Emirates in 2005 to that in 2008?
Provide a short and direct response. 0.87. What is the ratio of the Expenditure(as % of GDP) in Uzbekistan in 2005 to that in 2008?
Keep it short and to the point. 0.86. What is the ratio of the Expenditure(as % of GDP) of Armenia in 2005 to that in 2009?
Ensure brevity in your answer.  1.16. What is the ratio of the Expenditure(as % of GDP) of Norway in 2005 to that in 2009?
Provide a short and direct response. 0.93. What is the ratio of the Expenditure(as % of GDP) of United Arab Emirates in 2005 to that in 2009?
Make the answer very short. 0.64. What is the ratio of the Expenditure(as % of GDP) in Uzbekistan in 2005 to that in 2009?
Provide a short and direct response. 0.81. What is the ratio of the Expenditure(as % of GDP) of Armenia in 2005 to that in 2010?
Provide a short and direct response. 1.15. What is the ratio of the Expenditure(as % of GDP) of Norway in 2005 to that in 2010?
Provide a short and direct response. 0.96. What is the ratio of the Expenditure(as % of GDP) of United Arab Emirates in 2005 to that in 2010?
Offer a terse response. 0.68. What is the ratio of the Expenditure(as % of GDP) in Uzbekistan in 2005 to that in 2010?
Provide a short and direct response. 0.96. What is the ratio of the Expenditure(as % of GDP) in Armenia in 2006 to that in 2007?
Your answer should be very brief. 1.06. What is the ratio of the Expenditure(as % of GDP) in Norway in 2006 to that in 2007?
Keep it short and to the point. 0.98. What is the ratio of the Expenditure(as % of GDP) in United Arab Emirates in 2006 to that in 2007?
Your answer should be compact. 0.94. What is the ratio of the Expenditure(as % of GDP) in Uzbekistan in 2006 to that in 2007?
Give a very brief answer. 0.95. What is the ratio of the Expenditure(as % of GDP) of Armenia in 2006 to that in 2008?
Give a very brief answer. 1.2. What is the ratio of the Expenditure(as % of GDP) of United Arab Emirates in 2006 to that in 2008?
Keep it short and to the point. 0.87. What is the ratio of the Expenditure(as % of GDP) in Uzbekistan in 2006 to that in 2008?
Provide a succinct answer. 0.93. What is the ratio of the Expenditure(as % of GDP) of Armenia in 2006 to that in 2009?
Offer a very short reply. 1.01. What is the ratio of the Expenditure(as % of GDP) of Norway in 2006 to that in 2009?
Your answer should be very brief. 0.89. What is the ratio of the Expenditure(as % of GDP) in United Arab Emirates in 2006 to that in 2009?
Offer a terse response. 0.64. What is the ratio of the Expenditure(as % of GDP) of Uzbekistan in 2006 to that in 2009?
Provide a short and direct response. 0.87. What is the ratio of the Expenditure(as % of GDP) of Armenia in 2006 to that in 2010?
Your answer should be compact. 1. What is the ratio of the Expenditure(as % of GDP) in Norway in 2006 to that in 2010?
Provide a succinct answer. 0.91. What is the ratio of the Expenditure(as % of GDP) in United Arab Emirates in 2006 to that in 2010?
Offer a very short reply. 0.69. What is the ratio of the Expenditure(as % of GDP) in Uzbekistan in 2006 to that in 2010?
Make the answer very short. 1.03. What is the ratio of the Expenditure(as % of GDP) of Armenia in 2007 to that in 2008?
Offer a terse response. 1.13. What is the ratio of the Expenditure(as % of GDP) in Norway in 2007 to that in 2008?
Offer a terse response. 1.02. What is the ratio of the Expenditure(as % of GDP) in United Arab Emirates in 2007 to that in 2008?
Your answer should be very brief. 0.93. What is the ratio of the Expenditure(as % of GDP) in Uzbekistan in 2007 to that in 2008?
Make the answer very short. 0.98. What is the ratio of the Expenditure(as % of GDP) of Armenia in 2007 to that in 2009?
Provide a succinct answer. 0.95. What is the ratio of the Expenditure(as % of GDP) in Norway in 2007 to that in 2009?
Provide a succinct answer. 0.9. What is the ratio of the Expenditure(as % of GDP) in United Arab Emirates in 2007 to that in 2009?
Give a very brief answer. 0.68. What is the ratio of the Expenditure(as % of GDP) in Uzbekistan in 2007 to that in 2009?
Offer a terse response. 0.92. What is the ratio of the Expenditure(as % of GDP) of Armenia in 2007 to that in 2010?
Ensure brevity in your answer.  0.94. What is the ratio of the Expenditure(as % of GDP) in Norway in 2007 to that in 2010?
Provide a succinct answer. 0.93. What is the ratio of the Expenditure(as % of GDP) in United Arab Emirates in 2007 to that in 2010?
Make the answer very short. 0.73. What is the ratio of the Expenditure(as % of GDP) in Uzbekistan in 2007 to that in 2010?
Give a very brief answer. 1.09. What is the ratio of the Expenditure(as % of GDP) of Armenia in 2008 to that in 2009?
Provide a succinct answer. 0.84. What is the ratio of the Expenditure(as % of GDP) in Norway in 2008 to that in 2009?
Your answer should be compact. 0.88. What is the ratio of the Expenditure(as % of GDP) in United Arab Emirates in 2008 to that in 2009?
Give a very brief answer. 0.73. What is the ratio of the Expenditure(as % of GDP) of Uzbekistan in 2008 to that in 2009?
Provide a succinct answer. 0.94. What is the ratio of the Expenditure(as % of GDP) of Armenia in 2008 to that in 2010?
Offer a terse response. 0.83. What is the ratio of the Expenditure(as % of GDP) of Norway in 2008 to that in 2010?
Your response must be concise. 0.91. What is the ratio of the Expenditure(as % of GDP) of United Arab Emirates in 2008 to that in 2010?
Provide a succinct answer. 0.79. What is the ratio of the Expenditure(as % of GDP) of Uzbekistan in 2008 to that in 2010?
Ensure brevity in your answer.  1.11. What is the ratio of the Expenditure(as % of GDP) in Norway in 2009 to that in 2010?
Provide a succinct answer. 1.03. What is the ratio of the Expenditure(as % of GDP) in United Arab Emirates in 2009 to that in 2010?
Make the answer very short. 1.08. What is the ratio of the Expenditure(as % of GDP) in Uzbekistan in 2009 to that in 2010?
Make the answer very short. 1.18. What is the difference between the highest and the second highest Expenditure(as % of GDP) in Armenia?
Ensure brevity in your answer.  0.25. What is the difference between the highest and the second highest Expenditure(as % of GDP) of Norway?
Provide a succinct answer. 0.08. What is the difference between the highest and the second highest Expenditure(as % of GDP) in United Arab Emirates?
Keep it short and to the point. 0.26. What is the difference between the highest and the second highest Expenditure(as % of GDP) in Uzbekistan?
Ensure brevity in your answer.  0.39. What is the difference between the highest and the lowest Expenditure(as % of GDP) in Armenia?
Make the answer very short. 1.7. What is the difference between the highest and the lowest Expenditure(as % of GDP) of Norway?
Provide a succinct answer. 1.12. What is the difference between the highest and the lowest Expenditure(as % of GDP) in United Arab Emirates?
Offer a terse response. 1.33. What is the difference between the highest and the lowest Expenditure(as % of GDP) in Uzbekistan?
Provide a short and direct response. 1.2. 